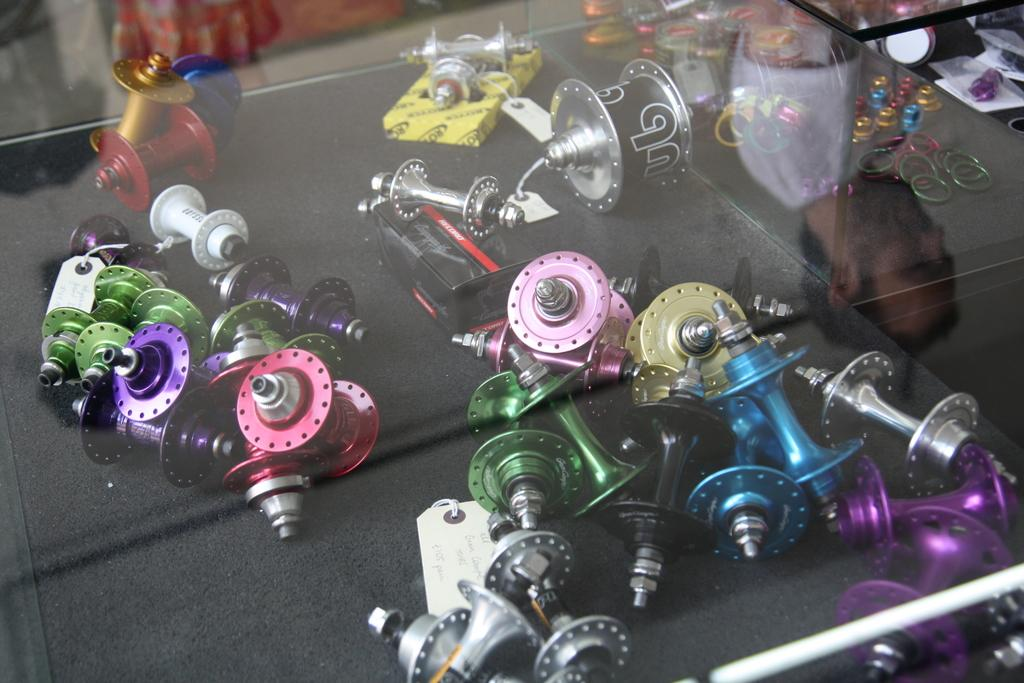What is contained within the glass frame in the image? There are objects inside a glass frame in the image. Can you describe the appearance of the objects? The objects have different colors. Is there any indication of a person in the image? Yes, there is a reflection of a person in the image. Can you tell me how many islands are visible in the image? There are no islands present in the image. What type of ball is being used by the person in the image? There is no ball present in the image, and the reflection of the person does not show any ball being used. 